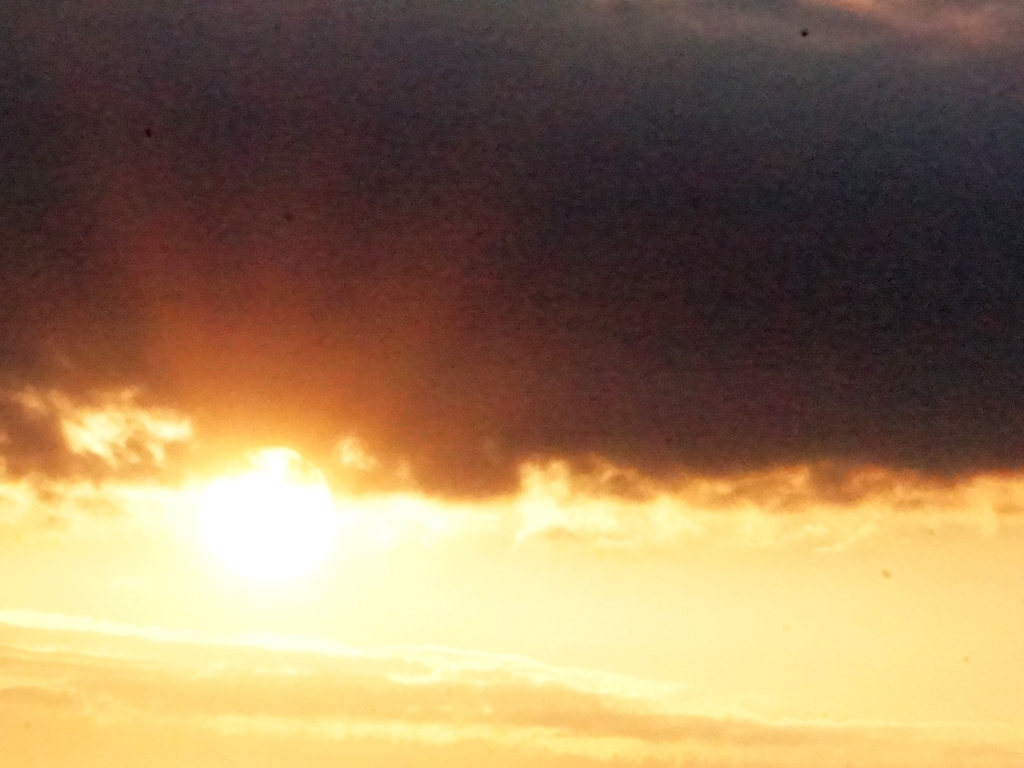What mood does this image evoke? The image evokes a sense of calm and reflection, possibly inspiring thoughts about the passing of time or the natural cycles of day and night. The muted clarity and interplay of light and shadows could also suggest introspection or serenity. 